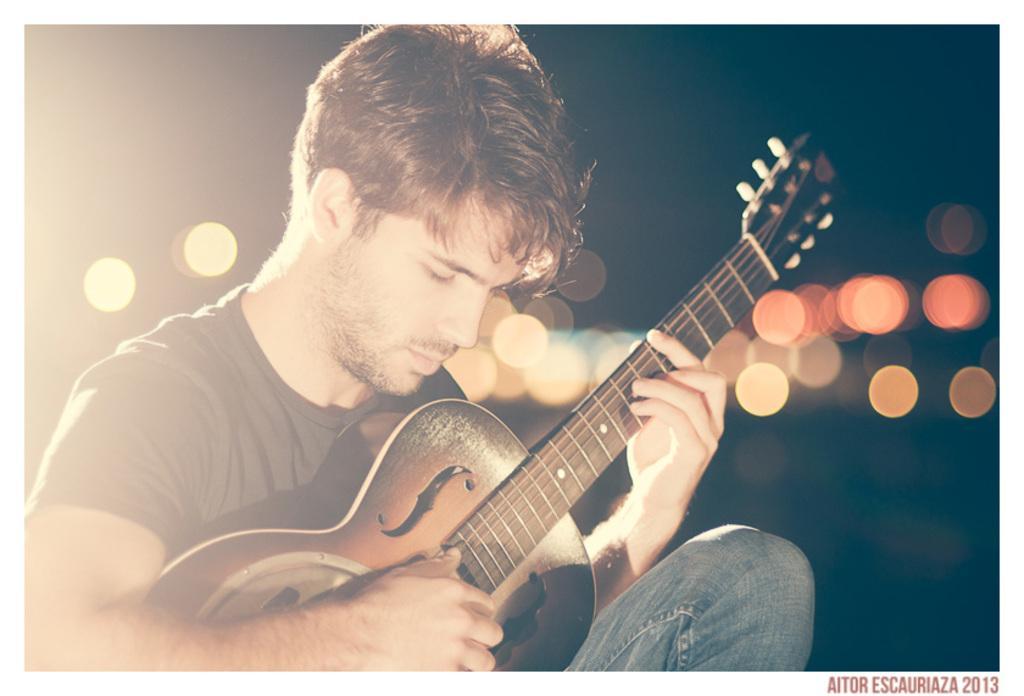How would you summarize this image in a sentence or two? In the image there is man playing guitar and back side of him there are lights. 